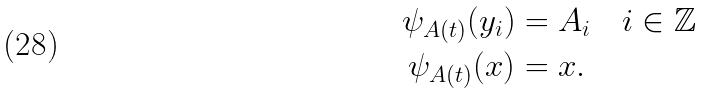<formula> <loc_0><loc_0><loc_500><loc_500>\psi _ { A ( t ) } ( y _ { i } ) & = A _ { i } \quad i \in \mathbb { Z } \\ \psi _ { A ( t ) } ( x ) & = x .</formula> 